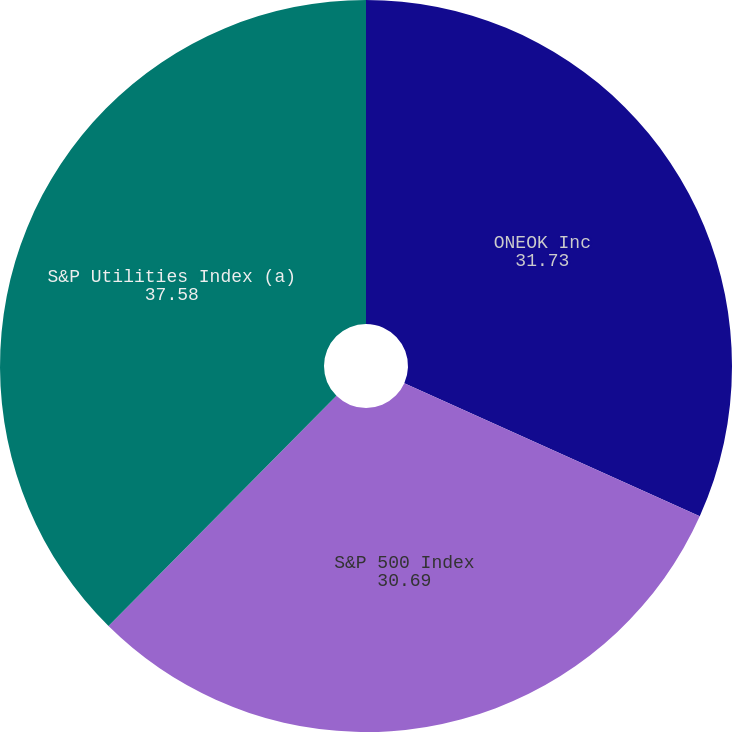<chart> <loc_0><loc_0><loc_500><loc_500><pie_chart><fcel>ONEOK Inc<fcel>S&P 500 Index<fcel>S&P Utilities Index (a)<nl><fcel>31.73%<fcel>30.69%<fcel>37.58%<nl></chart> 